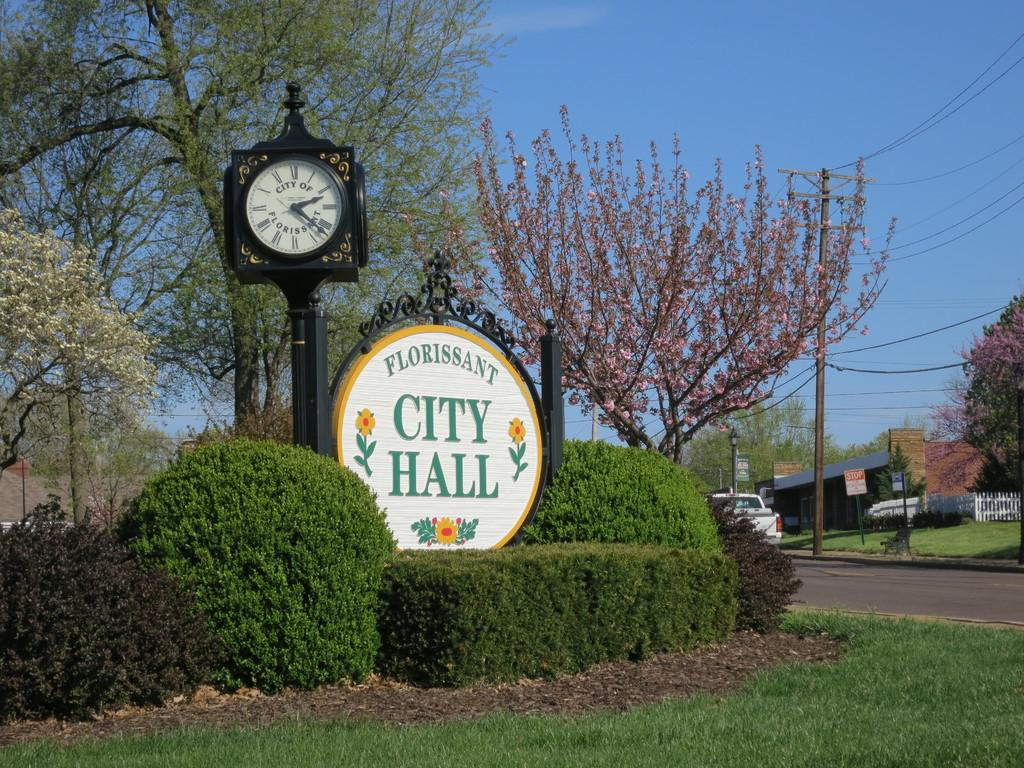<image>
Offer a succinct explanation of the picture presented. A picture of a black clock with the words City of Florissant printed on the face next to a sign that says Florrisant City Hall. 